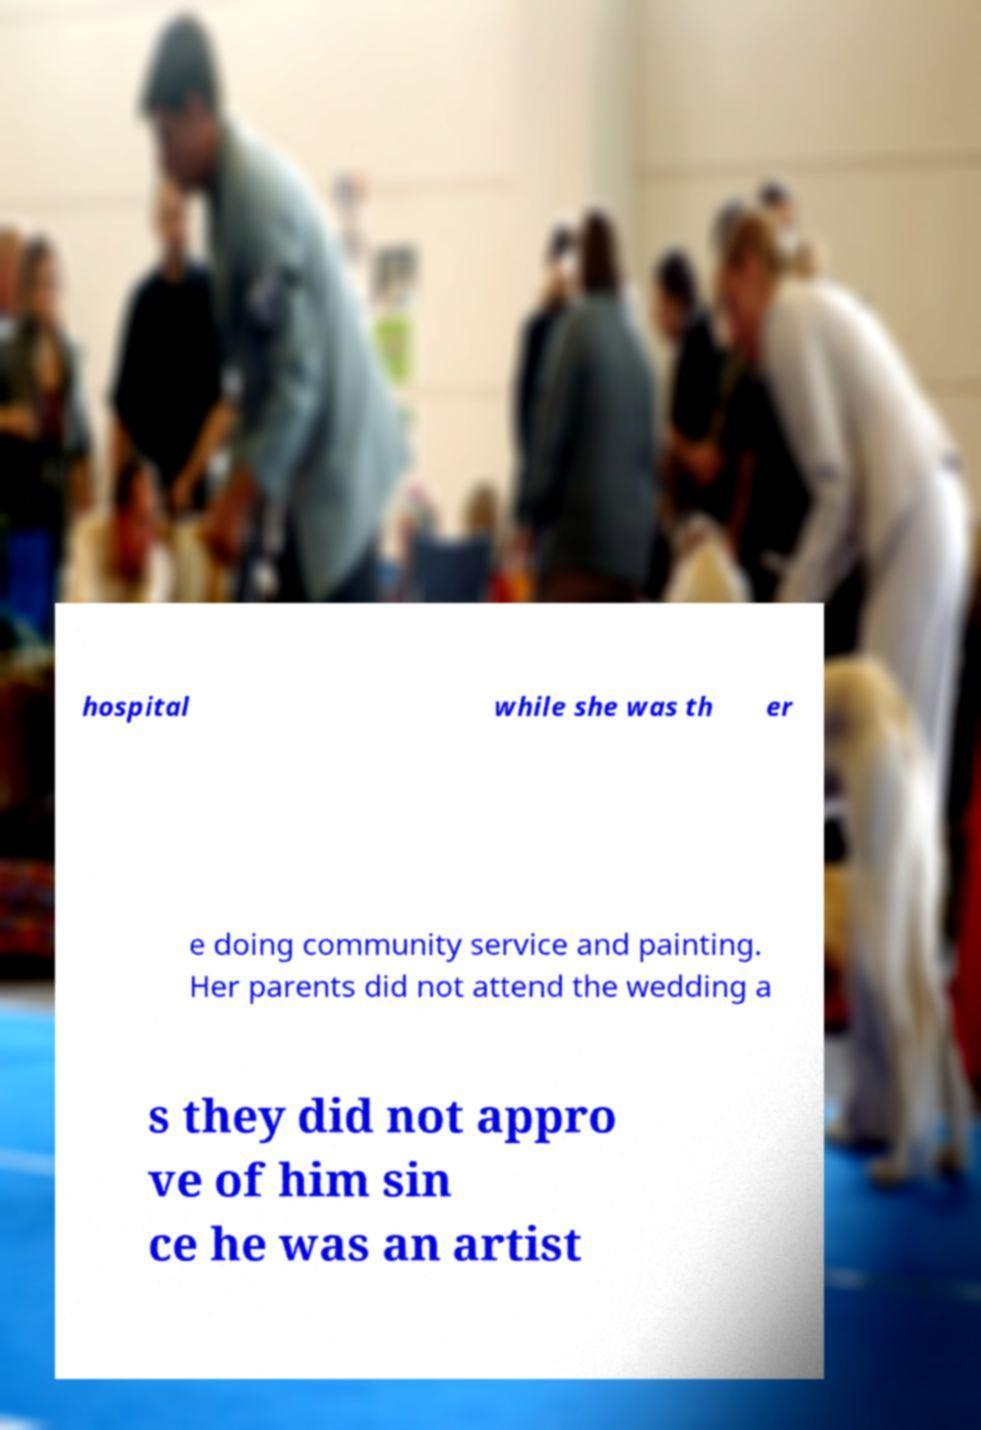What messages or text are displayed in this image? I need them in a readable, typed format. hospital while she was th er e doing community service and painting. Her parents did not attend the wedding a s they did not appro ve of him sin ce he was an artist 